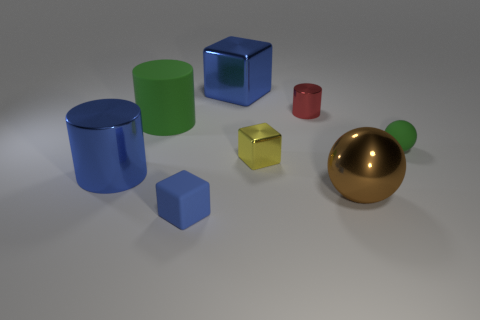How many tiny blocks have the same color as the large metallic block?
Offer a terse response. 1. Is there a metal block that has the same size as the green ball?
Give a very brief answer. Yes. What is the material of the red thing that is the same size as the green rubber sphere?
Keep it short and to the point. Metal. There is a shiny cylinder right of the big metal block; is its size the same as the green matte object that is in front of the big green matte thing?
Ensure brevity in your answer.  Yes. What number of objects are large brown metal spheres or things that are left of the tiny green thing?
Provide a succinct answer. 7. Is there another large metallic object that has the same shape as the yellow metallic thing?
Provide a short and direct response. Yes. What size is the blue metallic object in front of the metal cube in front of the big metallic block?
Keep it short and to the point. Large. Does the tiny matte ball have the same color as the big matte thing?
Keep it short and to the point. Yes. How many matte objects are big blue things or tiny cyan blocks?
Your answer should be compact. 0. How many tiny red matte cubes are there?
Make the answer very short. 0. 